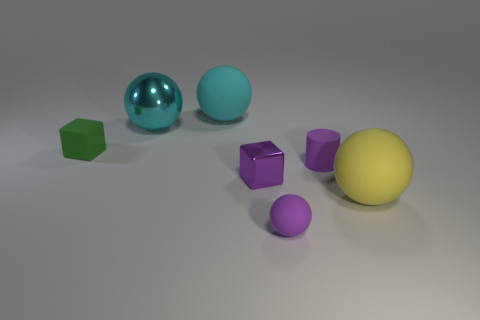What number of objects are either cyan balls or small metal blocks in front of the big shiny thing?
Your response must be concise. 3. What number of big balls are to the left of the rubber ball in front of the big object that is on the right side of the tiny cylinder?
Provide a succinct answer. 2. What material is the tiny ball that is the same color as the tiny cylinder?
Your response must be concise. Rubber. How many big brown cylinders are there?
Keep it short and to the point. 0. There is a purple object that is in front of the yellow rubber sphere; does it have the same size as the purple matte cylinder?
Offer a very short reply. Yes. How many metal things are either purple things or yellow spheres?
Make the answer very short. 1. There is a cube behind the small matte cylinder; how many rubber balls are on the left side of it?
Make the answer very short. 0. There is a small rubber thing that is right of the big cyan metallic ball and behind the yellow sphere; what shape is it?
Your answer should be very brief. Cylinder. There is a ball to the left of the matte ball behind the cube right of the tiny green matte cube; what is its material?
Make the answer very short. Metal. There is a cylinder that is the same color as the tiny metallic object; what is its size?
Provide a succinct answer. Small. 